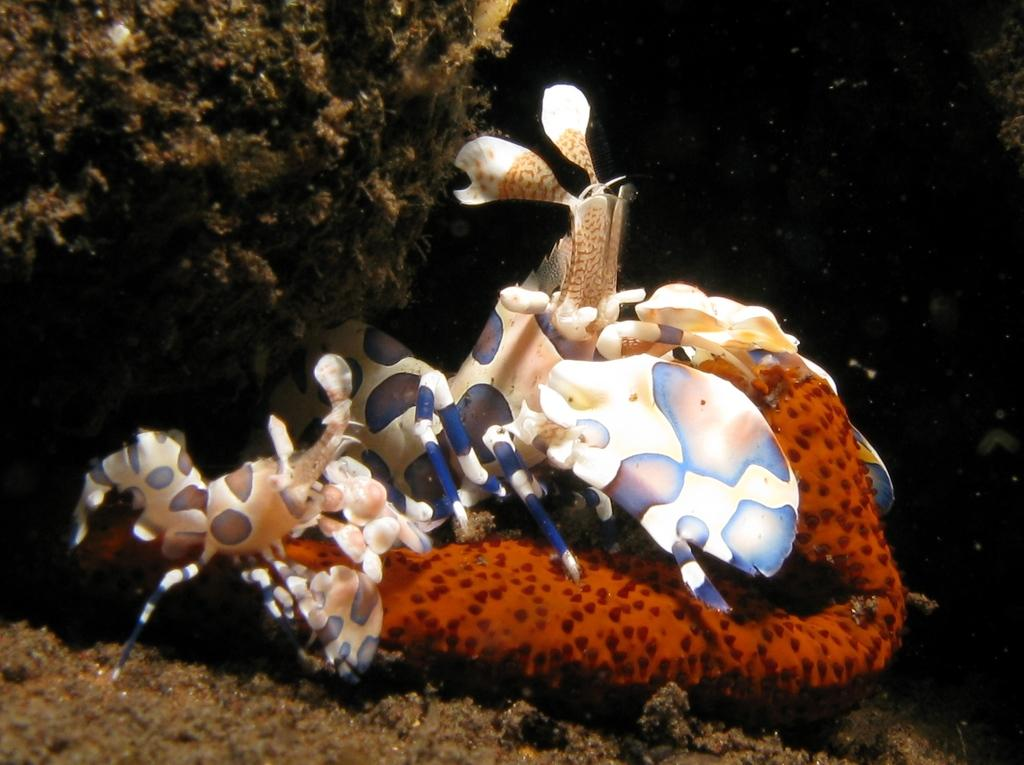What can be seen in the image? There is an object and trees in the image. Can you describe the object in the image? Unfortunately, the facts provided do not give enough information to describe the object in detail. What type of vegetation is present in the image? The vegetation in the image consists of trees. Where is the farmer standing in the image? There is no farmer present in the image. What is the relationship between the coast and the trees in the image? There is no coast present in the image, so it cannot be related to the trees. 